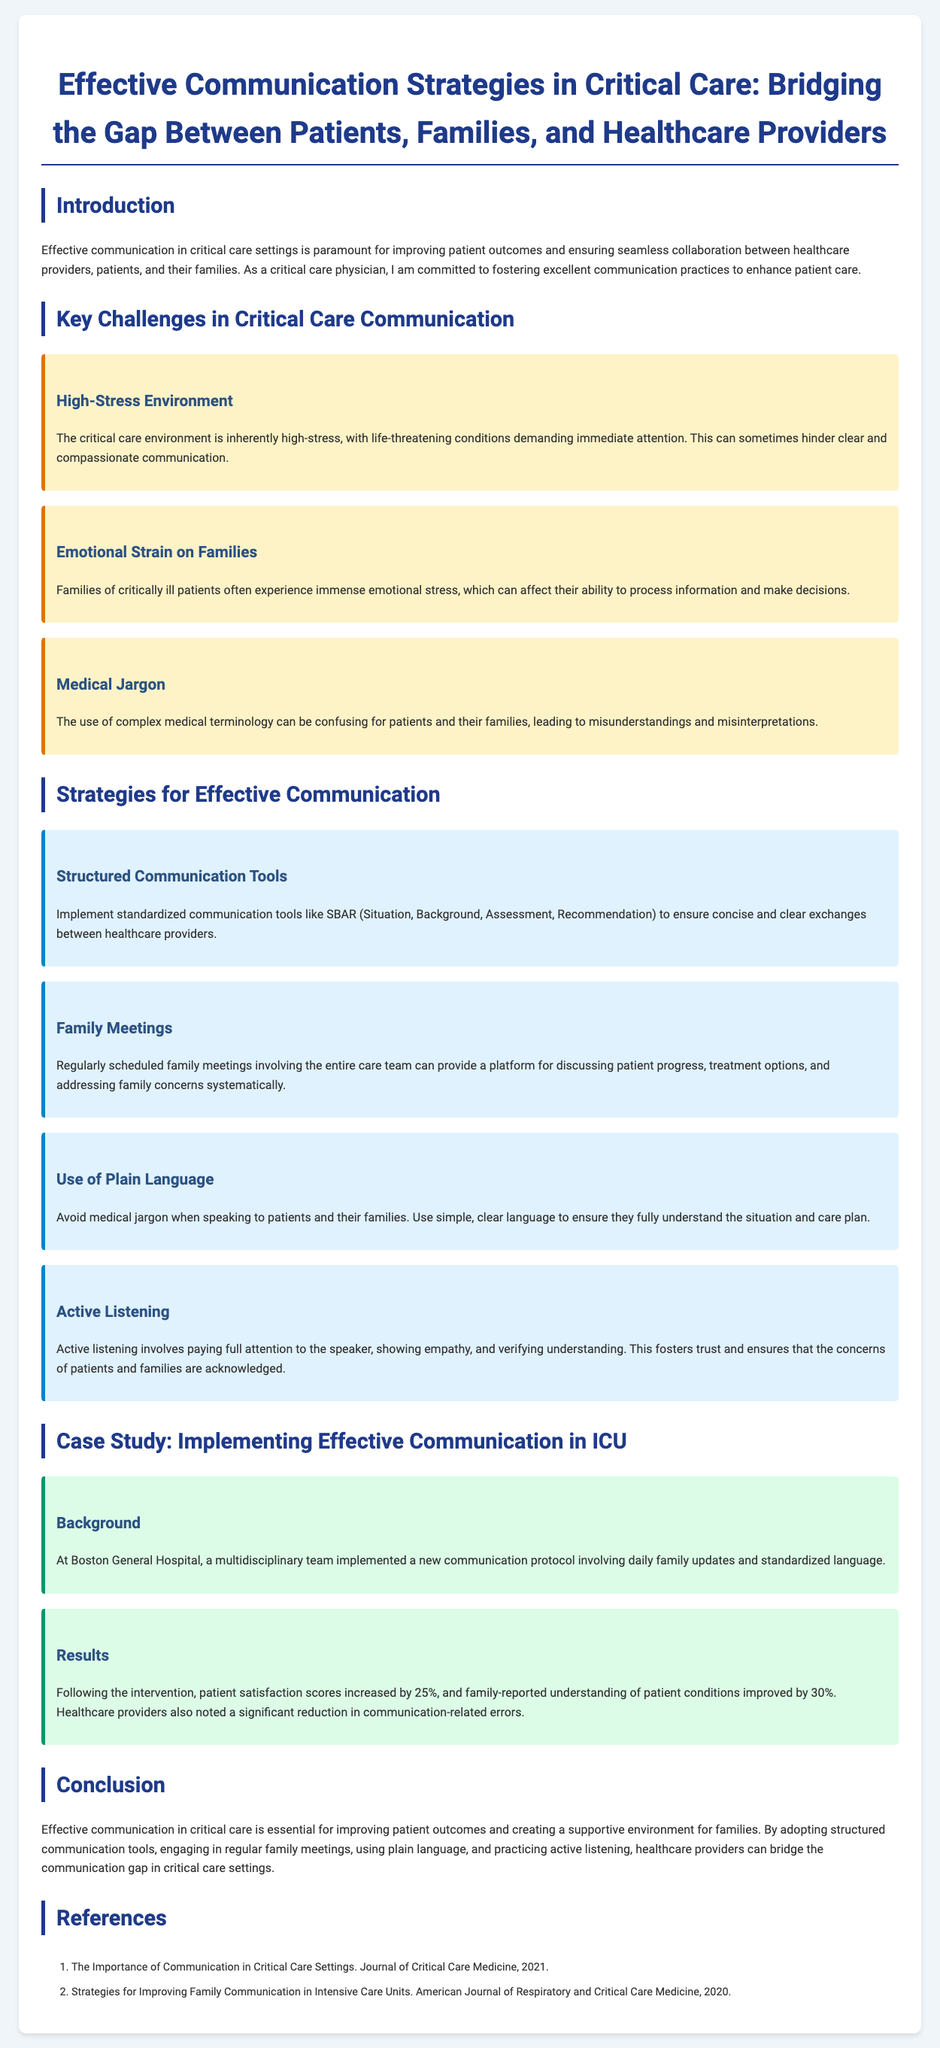What is the title of the whitepaper? The title of the whitepaper is stated at the top of the document.
Answer: Effective Communication Strategies in Critical Care: Bridging the Gap Between Patients, Families, and Healthcare Providers What is one key challenge in critical care communication? The section lists various challenges faced in critical care communication.
Answer: High-Stress Environment What is one strategy for effective communication mentioned? The document details several strategies for improving communication in critical care settings.
Answer: Structured Communication Tools What was the percentage increase in patient satisfaction scores after the implementation? The results of the case study indicate a measurable change following the new communication protocol.
Answer: 25% What is the year of the reference about communication in critical care settings? The reference section provides years for the cited studies within the document.
Answer: 2021 What type of language should healthcare providers use when speaking to patients and families? The document recommends a specific approach to language in communication with patients and families.
Answer: Plain Language What does active listening foster according to the document? The explanation in the document describes the effects of active listening on communication dynamics.
Answer: Trust How often should family meetings be scheduled according to the strategies provided? The document suggests a regular practice but does not specify an exact frequency.
Answer: Regularly What was implemented at Boston General Hospital? The case study describes a specific initiative taken by a hospital to improve communication.
Answer: A new communication protocol 